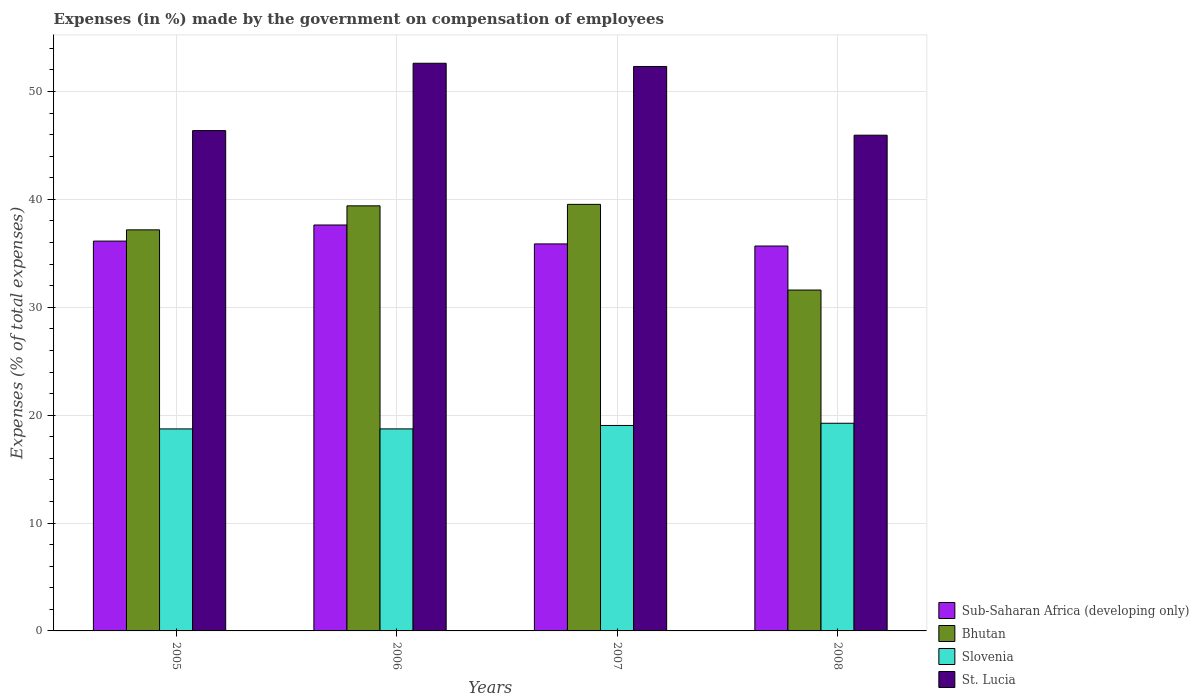How many different coloured bars are there?
Your response must be concise. 4. How many groups of bars are there?
Make the answer very short. 4. How many bars are there on the 2nd tick from the left?
Offer a very short reply. 4. What is the label of the 1st group of bars from the left?
Ensure brevity in your answer.  2005. What is the percentage of expenses made by the government on compensation of employees in St. Lucia in 2007?
Give a very brief answer. 52.32. Across all years, what is the maximum percentage of expenses made by the government on compensation of employees in Bhutan?
Your answer should be very brief. 39.54. Across all years, what is the minimum percentage of expenses made by the government on compensation of employees in St. Lucia?
Give a very brief answer. 45.95. In which year was the percentage of expenses made by the government on compensation of employees in St. Lucia maximum?
Provide a short and direct response. 2006. In which year was the percentage of expenses made by the government on compensation of employees in Bhutan minimum?
Offer a terse response. 2008. What is the total percentage of expenses made by the government on compensation of employees in Bhutan in the graph?
Make the answer very short. 147.72. What is the difference between the percentage of expenses made by the government on compensation of employees in Bhutan in 2005 and that in 2007?
Offer a very short reply. -2.36. What is the difference between the percentage of expenses made by the government on compensation of employees in St. Lucia in 2008 and the percentage of expenses made by the government on compensation of employees in Sub-Saharan Africa (developing only) in 2005?
Keep it short and to the point. 9.82. What is the average percentage of expenses made by the government on compensation of employees in Bhutan per year?
Ensure brevity in your answer.  36.93. In the year 2005, what is the difference between the percentage of expenses made by the government on compensation of employees in Slovenia and percentage of expenses made by the government on compensation of employees in Bhutan?
Ensure brevity in your answer.  -18.45. In how many years, is the percentage of expenses made by the government on compensation of employees in Slovenia greater than 52 %?
Your answer should be compact. 0. What is the ratio of the percentage of expenses made by the government on compensation of employees in Slovenia in 2007 to that in 2008?
Keep it short and to the point. 0.99. Is the percentage of expenses made by the government on compensation of employees in St. Lucia in 2006 less than that in 2008?
Offer a terse response. No. Is the difference between the percentage of expenses made by the government on compensation of employees in Slovenia in 2005 and 2007 greater than the difference between the percentage of expenses made by the government on compensation of employees in Bhutan in 2005 and 2007?
Offer a very short reply. Yes. What is the difference between the highest and the second highest percentage of expenses made by the government on compensation of employees in Bhutan?
Your answer should be compact. 0.14. What is the difference between the highest and the lowest percentage of expenses made by the government on compensation of employees in Bhutan?
Provide a succinct answer. 7.94. What does the 2nd bar from the left in 2005 represents?
Provide a succinct answer. Bhutan. What does the 3rd bar from the right in 2006 represents?
Your answer should be compact. Bhutan. Is it the case that in every year, the sum of the percentage of expenses made by the government on compensation of employees in Sub-Saharan Africa (developing only) and percentage of expenses made by the government on compensation of employees in Slovenia is greater than the percentage of expenses made by the government on compensation of employees in St. Lucia?
Offer a terse response. Yes. Are all the bars in the graph horizontal?
Make the answer very short. No. Are the values on the major ticks of Y-axis written in scientific E-notation?
Provide a short and direct response. No. Does the graph contain any zero values?
Your response must be concise. No. Where does the legend appear in the graph?
Give a very brief answer. Bottom right. What is the title of the graph?
Provide a succinct answer. Expenses (in %) made by the government on compensation of employees. What is the label or title of the X-axis?
Keep it short and to the point. Years. What is the label or title of the Y-axis?
Your answer should be compact. Expenses (% of total expenses). What is the Expenses (% of total expenses) of Sub-Saharan Africa (developing only) in 2005?
Offer a terse response. 36.14. What is the Expenses (% of total expenses) of Bhutan in 2005?
Your answer should be compact. 37.18. What is the Expenses (% of total expenses) of Slovenia in 2005?
Your answer should be compact. 18.73. What is the Expenses (% of total expenses) in St. Lucia in 2005?
Provide a short and direct response. 46.38. What is the Expenses (% of total expenses) in Sub-Saharan Africa (developing only) in 2006?
Provide a short and direct response. 37.63. What is the Expenses (% of total expenses) of Bhutan in 2006?
Make the answer very short. 39.4. What is the Expenses (% of total expenses) of Slovenia in 2006?
Your answer should be very brief. 18.73. What is the Expenses (% of total expenses) of St. Lucia in 2006?
Provide a succinct answer. 52.62. What is the Expenses (% of total expenses) in Sub-Saharan Africa (developing only) in 2007?
Make the answer very short. 35.87. What is the Expenses (% of total expenses) in Bhutan in 2007?
Keep it short and to the point. 39.54. What is the Expenses (% of total expenses) of Slovenia in 2007?
Provide a succinct answer. 19.05. What is the Expenses (% of total expenses) of St. Lucia in 2007?
Offer a terse response. 52.32. What is the Expenses (% of total expenses) of Sub-Saharan Africa (developing only) in 2008?
Your answer should be very brief. 35.68. What is the Expenses (% of total expenses) in Bhutan in 2008?
Make the answer very short. 31.6. What is the Expenses (% of total expenses) in Slovenia in 2008?
Your answer should be compact. 19.25. What is the Expenses (% of total expenses) in St. Lucia in 2008?
Provide a short and direct response. 45.95. Across all years, what is the maximum Expenses (% of total expenses) in Sub-Saharan Africa (developing only)?
Your answer should be very brief. 37.63. Across all years, what is the maximum Expenses (% of total expenses) of Bhutan?
Your answer should be compact. 39.54. Across all years, what is the maximum Expenses (% of total expenses) of Slovenia?
Provide a short and direct response. 19.25. Across all years, what is the maximum Expenses (% of total expenses) of St. Lucia?
Provide a short and direct response. 52.62. Across all years, what is the minimum Expenses (% of total expenses) of Sub-Saharan Africa (developing only)?
Your answer should be very brief. 35.68. Across all years, what is the minimum Expenses (% of total expenses) of Bhutan?
Make the answer very short. 31.6. Across all years, what is the minimum Expenses (% of total expenses) of Slovenia?
Give a very brief answer. 18.73. Across all years, what is the minimum Expenses (% of total expenses) in St. Lucia?
Offer a terse response. 45.95. What is the total Expenses (% of total expenses) of Sub-Saharan Africa (developing only) in the graph?
Keep it short and to the point. 145.32. What is the total Expenses (% of total expenses) of Bhutan in the graph?
Your answer should be very brief. 147.72. What is the total Expenses (% of total expenses) of Slovenia in the graph?
Offer a terse response. 75.75. What is the total Expenses (% of total expenses) in St. Lucia in the graph?
Ensure brevity in your answer.  197.27. What is the difference between the Expenses (% of total expenses) in Sub-Saharan Africa (developing only) in 2005 and that in 2006?
Make the answer very short. -1.49. What is the difference between the Expenses (% of total expenses) of Bhutan in 2005 and that in 2006?
Provide a succinct answer. -2.23. What is the difference between the Expenses (% of total expenses) in Slovenia in 2005 and that in 2006?
Your response must be concise. -0. What is the difference between the Expenses (% of total expenses) of St. Lucia in 2005 and that in 2006?
Provide a succinct answer. -6.24. What is the difference between the Expenses (% of total expenses) in Sub-Saharan Africa (developing only) in 2005 and that in 2007?
Provide a short and direct response. 0.26. What is the difference between the Expenses (% of total expenses) of Bhutan in 2005 and that in 2007?
Provide a short and direct response. -2.36. What is the difference between the Expenses (% of total expenses) of Slovenia in 2005 and that in 2007?
Your answer should be compact. -0.32. What is the difference between the Expenses (% of total expenses) of St. Lucia in 2005 and that in 2007?
Make the answer very short. -5.95. What is the difference between the Expenses (% of total expenses) of Sub-Saharan Africa (developing only) in 2005 and that in 2008?
Ensure brevity in your answer.  0.46. What is the difference between the Expenses (% of total expenses) of Bhutan in 2005 and that in 2008?
Give a very brief answer. 5.58. What is the difference between the Expenses (% of total expenses) in Slovenia in 2005 and that in 2008?
Provide a short and direct response. -0.52. What is the difference between the Expenses (% of total expenses) of St. Lucia in 2005 and that in 2008?
Offer a very short reply. 0.42. What is the difference between the Expenses (% of total expenses) of Sub-Saharan Africa (developing only) in 2006 and that in 2007?
Your answer should be very brief. 1.75. What is the difference between the Expenses (% of total expenses) of Bhutan in 2006 and that in 2007?
Your answer should be compact. -0.14. What is the difference between the Expenses (% of total expenses) in Slovenia in 2006 and that in 2007?
Your answer should be compact. -0.32. What is the difference between the Expenses (% of total expenses) in St. Lucia in 2006 and that in 2007?
Offer a very short reply. 0.3. What is the difference between the Expenses (% of total expenses) of Sub-Saharan Africa (developing only) in 2006 and that in 2008?
Make the answer very short. 1.95. What is the difference between the Expenses (% of total expenses) of Bhutan in 2006 and that in 2008?
Make the answer very short. 7.8. What is the difference between the Expenses (% of total expenses) of Slovenia in 2006 and that in 2008?
Provide a succinct answer. -0.52. What is the difference between the Expenses (% of total expenses) in St. Lucia in 2006 and that in 2008?
Offer a very short reply. 6.67. What is the difference between the Expenses (% of total expenses) in Sub-Saharan Africa (developing only) in 2007 and that in 2008?
Make the answer very short. 0.2. What is the difference between the Expenses (% of total expenses) in Bhutan in 2007 and that in 2008?
Give a very brief answer. 7.94. What is the difference between the Expenses (% of total expenses) of Slovenia in 2007 and that in 2008?
Keep it short and to the point. -0.2. What is the difference between the Expenses (% of total expenses) of St. Lucia in 2007 and that in 2008?
Make the answer very short. 6.37. What is the difference between the Expenses (% of total expenses) in Sub-Saharan Africa (developing only) in 2005 and the Expenses (% of total expenses) in Bhutan in 2006?
Your answer should be compact. -3.27. What is the difference between the Expenses (% of total expenses) in Sub-Saharan Africa (developing only) in 2005 and the Expenses (% of total expenses) in Slovenia in 2006?
Offer a very short reply. 17.41. What is the difference between the Expenses (% of total expenses) in Sub-Saharan Africa (developing only) in 2005 and the Expenses (% of total expenses) in St. Lucia in 2006?
Provide a succinct answer. -16.48. What is the difference between the Expenses (% of total expenses) in Bhutan in 2005 and the Expenses (% of total expenses) in Slovenia in 2006?
Make the answer very short. 18.45. What is the difference between the Expenses (% of total expenses) in Bhutan in 2005 and the Expenses (% of total expenses) in St. Lucia in 2006?
Your answer should be compact. -15.44. What is the difference between the Expenses (% of total expenses) in Slovenia in 2005 and the Expenses (% of total expenses) in St. Lucia in 2006?
Provide a succinct answer. -33.89. What is the difference between the Expenses (% of total expenses) of Sub-Saharan Africa (developing only) in 2005 and the Expenses (% of total expenses) of Bhutan in 2007?
Make the answer very short. -3.4. What is the difference between the Expenses (% of total expenses) in Sub-Saharan Africa (developing only) in 2005 and the Expenses (% of total expenses) in Slovenia in 2007?
Your answer should be compact. 17.09. What is the difference between the Expenses (% of total expenses) in Sub-Saharan Africa (developing only) in 2005 and the Expenses (% of total expenses) in St. Lucia in 2007?
Ensure brevity in your answer.  -16.19. What is the difference between the Expenses (% of total expenses) in Bhutan in 2005 and the Expenses (% of total expenses) in Slovenia in 2007?
Give a very brief answer. 18.13. What is the difference between the Expenses (% of total expenses) of Bhutan in 2005 and the Expenses (% of total expenses) of St. Lucia in 2007?
Ensure brevity in your answer.  -15.14. What is the difference between the Expenses (% of total expenses) in Slovenia in 2005 and the Expenses (% of total expenses) in St. Lucia in 2007?
Provide a short and direct response. -33.6. What is the difference between the Expenses (% of total expenses) of Sub-Saharan Africa (developing only) in 2005 and the Expenses (% of total expenses) of Bhutan in 2008?
Your response must be concise. 4.54. What is the difference between the Expenses (% of total expenses) in Sub-Saharan Africa (developing only) in 2005 and the Expenses (% of total expenses) in Slovenia in 2008?
Your answer should be very brief. 16.89. What is the difference between the Expenses (% of total expenses) of Sub-Saharan Africa (developing only) in 2005 and the Expenses (% of total expenses) of St. Lucia in 2008?
Give a very brief answer. -9.81. What is the difference between the Expenses (% of total expenses) of Bhutan in 2005 and the Expenses (% of total expenses) of Slovenia in 2008?
Offer a very short reply. 17.93. What is the difference between the Expenses (% of total expenses) of Bhutan in 2005 and the Expenses (% of total expenses) of St. Lucia in 2008?
Offer a terse response. -8.77. What is the difference between the Expenses (% of total expenses) of Slovenia in 2005 and the Expenses (% of total expenses) of St. Lucia in 2008?
Offer a very short reply. -27.23. What is the difference between the Expenses (% of total expenses) in Sub-Saharan Africa (developing only) in 2006 and the Expenses (% of total expenses) in Bhutan in 2007?
Make the answer very short. -1.91. What is the difference between the Expenses (% of total expenses) of Sub-Saharan Africa (developing only) in 2006 and the Expenses (% of total expenses) of Slovenia in 2007?
Offer a terse response. 18.58. What is the difference between the Expenses (% of total expenses) in Sub-Saharan Africa (developing only) in 2006 and the Expenses (% of total expenses) in St. Lucia in 2007?
Your answer should be very brief. -14.69. What is the difference between the Expenses (% of total expenses) in Bhutan in 2006 and the Expenses (% of total expenses) in Slovenia in 2007?
Keep it short and to the point. 20.36. What is the difference between the Expenses (% of total expenses) in Bhutan in 2006 and the Expenses (% of total expenses) in St. Lucia in 2007?
Give a very brief answer. -12.92. What is the difference between the Expenses (% of total expenses) in Slovenia in 2006 and the Expenses (% of total expenses) in St. Lucia in 2007?
Your answer should be very brief. -33.6. What is the difference between the Expenses (% of total expenses) of Sub-Saharan Africa (developing only) in 2006 and the Expenses (% of total expenses) of Bhutan in 2008?
Provide a short and direct response. 6.03. What is the difference between the Expenses (% of total expenses) of Sub-Saharan Africa (developing only) in 2006 and the Expenses (% of total expenses) of Slovenia in 2008?
Keep it short and to the point. 18.38. What is the difference between the Expenses (% of total expenses) of Sub-Saharan Africa (developing only) in 2006 and the Expenses (% of total expenses) of St. Lucia in 2008?
Offer a very short reply. -8.32. What is the difference between the Expenses (% of total expenses) in Bhutan in 2006 and the Expenses (% of total expenses) in Slovenia in 2008?
Give a very brief answer. 20.15. What is the difference between the Expenses (% of total expenses) in Bhutan in 2006 and the Expenses (% of total expenses) in St. Lucia in 2008?
Make the answer very short. -6.55. What is the difference between the Expenses (% of total expenses) of Slovenia in 2006 and the Expenses (% of total expenses) of St. Lucia in 2008?
Your response must be concise. -27.23. What is the difference between the Expenses (% of total expenses) in Sub-Saharan Africa (developing only) in 2007 and the Expenses (% of total expenses) in Bhutan in 2008?
Provide a succinct answer. 4.28. What is the difference between the Expenses (% of total expenses) in Sub-Saharan Africa (developing only) in 2007 and the Expenses (% of total expenses) in Slovenia in 2008?
Provide a short and direct response. 16.62. What is the difference between the Expenses (% of total expenses) of Sub-Saharan Africa (developing only) in 2007 and the Expenses (% of total expenses) of St. Lucia in 2008?
Provide a short and direct response. -10.08. What is the difference between the Expenses (% of total expenses) in Bhutan in 2007 and the Expenses (% of total expenses) in Slovenia in 2008?
Keep it short and to the point. 20.29. What is the difference between the Expenses (% of total expenses) in Bhutan in 2007 and the Expenses (% of total expenses) in St. Lucia in 2008?
Your answer should be very brief. -6.41. What is the difference between the Expenses (% of total expenses) of Slovenia in 2007 and the Expenses (% of total expenses) of St. Lucia in 2008?
Provide a short and direct response. -26.91. What is the average Expenses (% of total expenses) in Sub-Saharan Africa (developing only) per year?
Offer a very short reply. 36.33. What is the average Expenses (% of total expenses) in Bhutan per year?
Give a very brief answer. 36.93. What is the average Expenses (% of total expenses) of Slovenia per year?
Keep it short and to the point. 18.94. What is the average Expenses (% of total expenses) in St. Lucia per year?
Offer a very short reply. 49.32. In the year 2005, what is the difference between the Expenses (% of total expenses) in Sub-Saharan Africa (developing only) and Expenses (% of total expenses) in Bhutan?
Your response must be concise. -1.04. In the year 2005, what is the difference between the Expenses (% of total expenses) of Sub-Saharan Africa (developing only) and Expenses (% of total expenses) of Slovenia?
Your answer should be very brief. 17.41. In the year 2005, what is the difference between the Expenses (% of total expenses) of Sub-Saharan Africa (developing only) and Expenses (% of total expenses) of St. Lucia?
Your response must be concise. -10.24. In the year 2005, what is the difference between the Expenses (% of total expenses) of Bhutan and Expenses (% of total expenses) of Slovenia?
Offer a very short reply. 18.45. In the year 2005, what is the difference between the Expenses (% of total expenses) in Bhutan and Expenses (% of total expenses) in St. Lucia?
Give a very brief answer. -9.2. In the year 2005, what is the difference between the Expenses (% of total expenses) of Slovenia and Expenses (% of total expenses) of St. Lucia?
Give a very brief answer. -27.65. In the year 2006, what is the difference between the Expenses (% of total expenses) of Sub-Saharan Africa (developing only) and Expenses (% of total expenses) of Bhutan?
Your answer should be very brief. -1.77. In the year 2006, what is the difference between the Expenses (% of total expenses) in Sub-Saharan Africa (developing only) and Expenses (% of total expenses) in Slovenia?
Give a very brief answer. 18.9. In the year 2006, what is the difference between the Expenses (% of total expenses) in Sub-Saharan Africa (developing only) and Expenses (% of total expenses) in St. Lucia?
Offer a very short reply. -14.99. In the year 2006, what is the difference between the Expenses (% of total expenses) in Bhutan and Expenses (% of total expenses) in Slovenia?
Offer a very short reply. 20.68. In the year 2006, what is the difference between the Expenses (% of total expenses) in Bhutan and Expenses (% of total expenses) in St. Lucia?
Give a very brief answer. -13.22. In the year 2006, what is the difference between the Expenses (% of total expenses) of Slovenia and Expenses (% of total expenses) of St. Lucia?
Your response must be concise. -33.89. In the year 2007, what is the difference between the Expenses (% of total expenses) in Sub-Saharan Africa (developing only) and Expenses (% of total expenses) in Bhutan?
Your answer should be very brief. -3.67. In the year 2007, what is the difference between the Expenses (% of total expenses) in Sub-Saharan Africa (developing only) and Expenses (% of total expenses) in Slovenia?
Keep it short and to the point. 16.83. In the year 2007, what is the difference between the Expenses (% of total expenses) in Sub-Saharan Africa (developing only) and Expenses (% of total expenses) in St. Lucia?
Ensure brevity in your answer.  -16.45. In the year 2007, what is the difference between the Expenses (% of total expenses) of Bhutan and Expenses (% of total expenses) of Slovenia?
Offer a very short reply. 20.49. In the year 2007, what is the difference between the Expenses (% of total expenses) in Bhutan and Expenses (% of total expenses) in St. Lucia?
Your response must be concise. -12.78. In the year 2007, what is the difference between the Expenses (% of total expenses) in Slovenia and Expenses (% of total expenses) in St. Lucia?
Keep it short and to the point. -33.28. In the year 2008, what is the difference between the Expenses (% of total expenses) in Sub-Saharan Africa (developing only) and Expenses (% of total expenses) in Bhutan?
Your answer should be very brief. 4.08. In the year 2008, what is the difference between the Expenses (% of total expenses) of Sub-Saharan Africa (developing only) and Expenses (% of total expenses) of Slovenia?
Provide a short and direct response. 16.43. In the year 2008, what is the difference between the Expenses (% of total expenses) in Sub-Saharan Africa (developing only) and Expenses (% of total expenses) in St. Lucia?
Keep it short and to the point. -10.27. In the year 2008, what is the difference between the Expenses (% of total expenses) of Bhutan and Expenses (% of total expenses) of Slovenia?
Ensure brevity in your answer.  12.35. In the year 2008, what is the difference between the Expenses (% of total expenses) of Bhutan and Expenses (% of total expenses) of St. Lucia?
Your answer should be very brief. -14.35. In the year 2008, what is the difference between the Expenses (% of total expenses) of Slovenia and Expenses (% of total expenses) of St. Lucia?
Keep it short and to the point. -26.7. What is the ratio of the Expenses (% of total expenses) of Sub-Saharan Africa (developing only) in 2005 to that in 2006?
Provide a short and direct response. 0.96. What is the ratio of the Expenses (% of total expenses) of Bhutan in 2005 to that in 2006?
Your answer should be very brief. 0.94. What is the ratio of the Expenses (% of total expenses) of Slovenia in 2005 to that in 2006?
Keep it short and to the point. 1. What is the ratio of the Expenses (% of total expenses) in St. Lucia in 2005 to that in 2006?
Your response must be concise. 0.88. What is the ratio of the Expenses (% of total expenses) in Sub-Saharan Africa (developing only) in 2005 to that in 2007?
Make the answer very short. 1.01. What is the ratio of the Expenses (% of total expenses) of Bhutan in 2005 to that in 2007?
Provide a short and direct response. 0.94. What is the ratio of the Expenses (% of total expenses) in Slovenia in 2005 to that in 2007?
Your answer should be very brief. 0.98. What is the ratio of the Expenses (% of total expenses) of St. Lucia in 2005 to that in 2007?
Keep it short and to the point. 0.89. What is the ratio of the Expenses (% of total expenses) in Sub-Saharan Africa (developing only) in 2005 to that in 2008?
Your answer should be compact. 1.01. What is the ratio of the Expenses (% of total expenses) in Bhutan in 2005 to that in 2008?
Offer a very short reply. 1.18. What is the ratio of the Expenses (% of total expenses) in Slovenia in 2005 to that in 2008?
Provide a short and direct response. 0.97. What is the ratio of the Expenses (% of total expenses) in St. Lucia in 2005 to that in 2008?
Give a very brief answer. 1.01. What is the ratio of the Expenses (% of total expenses) in Sub-Saharan Africa (developing only) in 2006 to that in 2007?
Provide a succinct answer. 1.05. What is the ratio of the Expenses (% of total expenses) in Bhutan in 2006 to that in 2007?
Provide a succinct answer. 1. What is the ratio of the Expenses (% of total expenses) in Slovenia in 2006 to that in 2007?
Your answer should be compact. 0.98. What is the ratio of the Expenses (% of total expenses) in Sub-Saharan Africa (developing only) in 2006 to that in 2008?
Make the answer very short. 1.05. What is the ratio of the Expenses (% of total expenses) of Bhutan in 2006 to that in 2008?
Your answer should be very brief. 1.25. What is the ratio of the Expenses (% of total expenses) in Slovenia in 2006 to that in 2008?
Provide a succinct answer. 0.97. What is the ratio of the Expenses (% of total expenses) in St. Lucia in 2006 to that in 2008?
Your answer should be very brief. 1.15. What is the ratio of the Expenses (% of total expenses) of Sub-Saharan Africa (developing only) in 2007 to that in 2008?
Offer a very short reply. 1.01. What is the ratio of the Expenses (% of total expenses) of Bhutan in 2007 to that in 2008?
Your answer should be very brief. 1.25. What is the ratio of the Expenses (% of total expenses) in St. Lucia in 2007 to that in 2008?
Offer a very short reply. 1.14. What is the difference between the highest and the second highest Expenses (% of total expenses) of Sub-Saharan Africa (developing only)?
Ensure brevity in your answer.  1.49. What is the difference between the highest and the second highest Expenses (% of total expenses) of Bhutan?
Ensure brevity in your answer.  0.14. What is the difference between the highest and the second highest Expenses (% of total expenses) in Slovenia?
Provide a short and direct response. 0.2. What is the difference between the highest and the second highest Expenses (% of total expenses) in St. Lucia?
Keep it short and to the point. 0.3. What is the difference between the highest and the lowest Expenses (% of total expenses) in Sub-Saharan Africa (developing only)?
Make the answer very short. 1.95. What is the difference between the highest and the lowest Expenses (% of total expenses) in Bhutan?
Provide a short and direct response. 7.94. What is the difference between the highest and the lowest Expenses (% of total expenses) in Slovenia?
Provide a succinct answer. 0.52. What is the difference between the highest and the lowest Expenses (% of total expenses) of St. Lucia?
Ensure brevity in your answer.  6.67. 